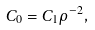Convert formula to latex. <formula><loc_0><loc_0><loc_500><loc_500>C _ { 0 } = C _ { 1 } \rho ^ { - 2 } ,</formula> 